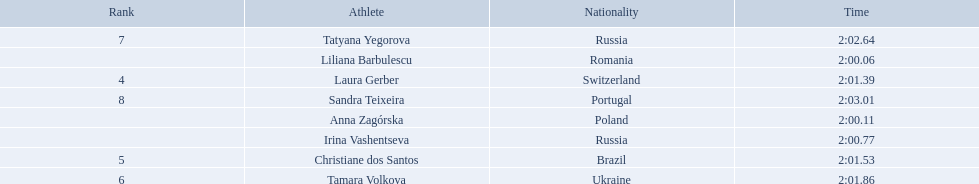What are the names of the competitors? Liliana Barbulescu, Anna Zagórska, Irina Vashentseva, Laura Gerber, Christiane dos Santos, Tamara Volkova, Tatyana Yegorova, Sandra Teixeira. Which finalist finished the fastest? Liliana Barbulescu. 